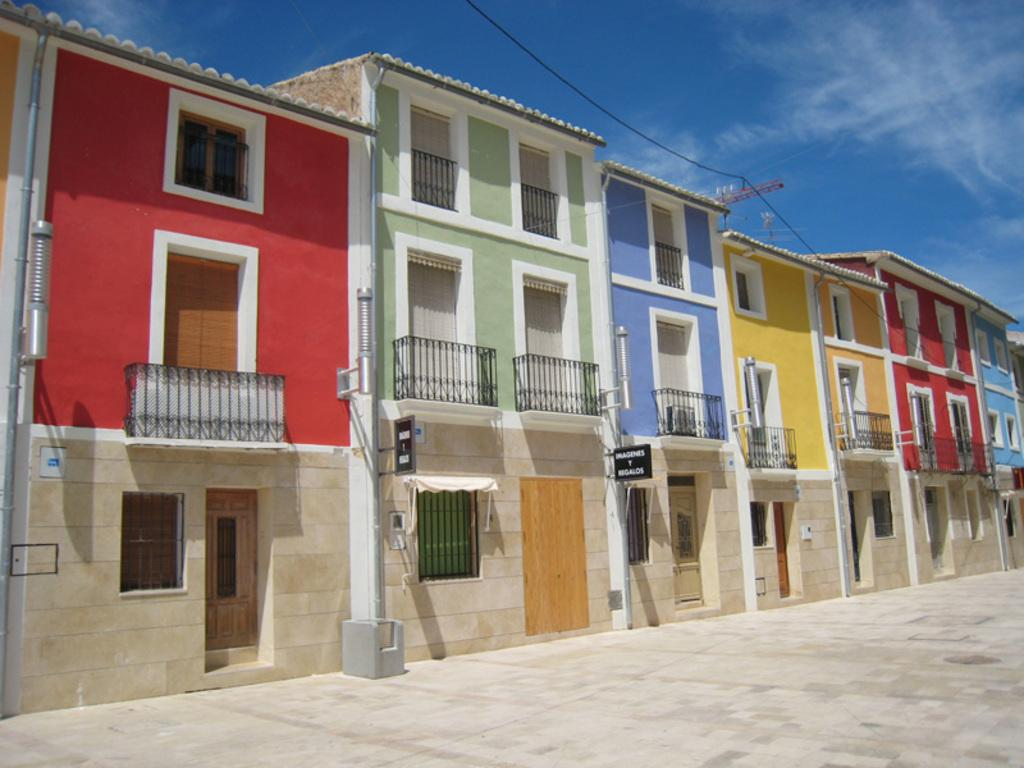What type of structures are present in the image? There are buildings in the image. What features can be seen on the buildings? The buildings have windows, railings, and doors. Are there any signs or markings on the buildings? Yes, there are boards with names in the image. What can be seen in the background of the image? The sky is visible in the background of the image, and there are clouds in the sky. How many cherries are hanging from the railings of the buildings in the image? There are no cherries present in the image; the buildings have railings, but no cherries are hanging from them. 